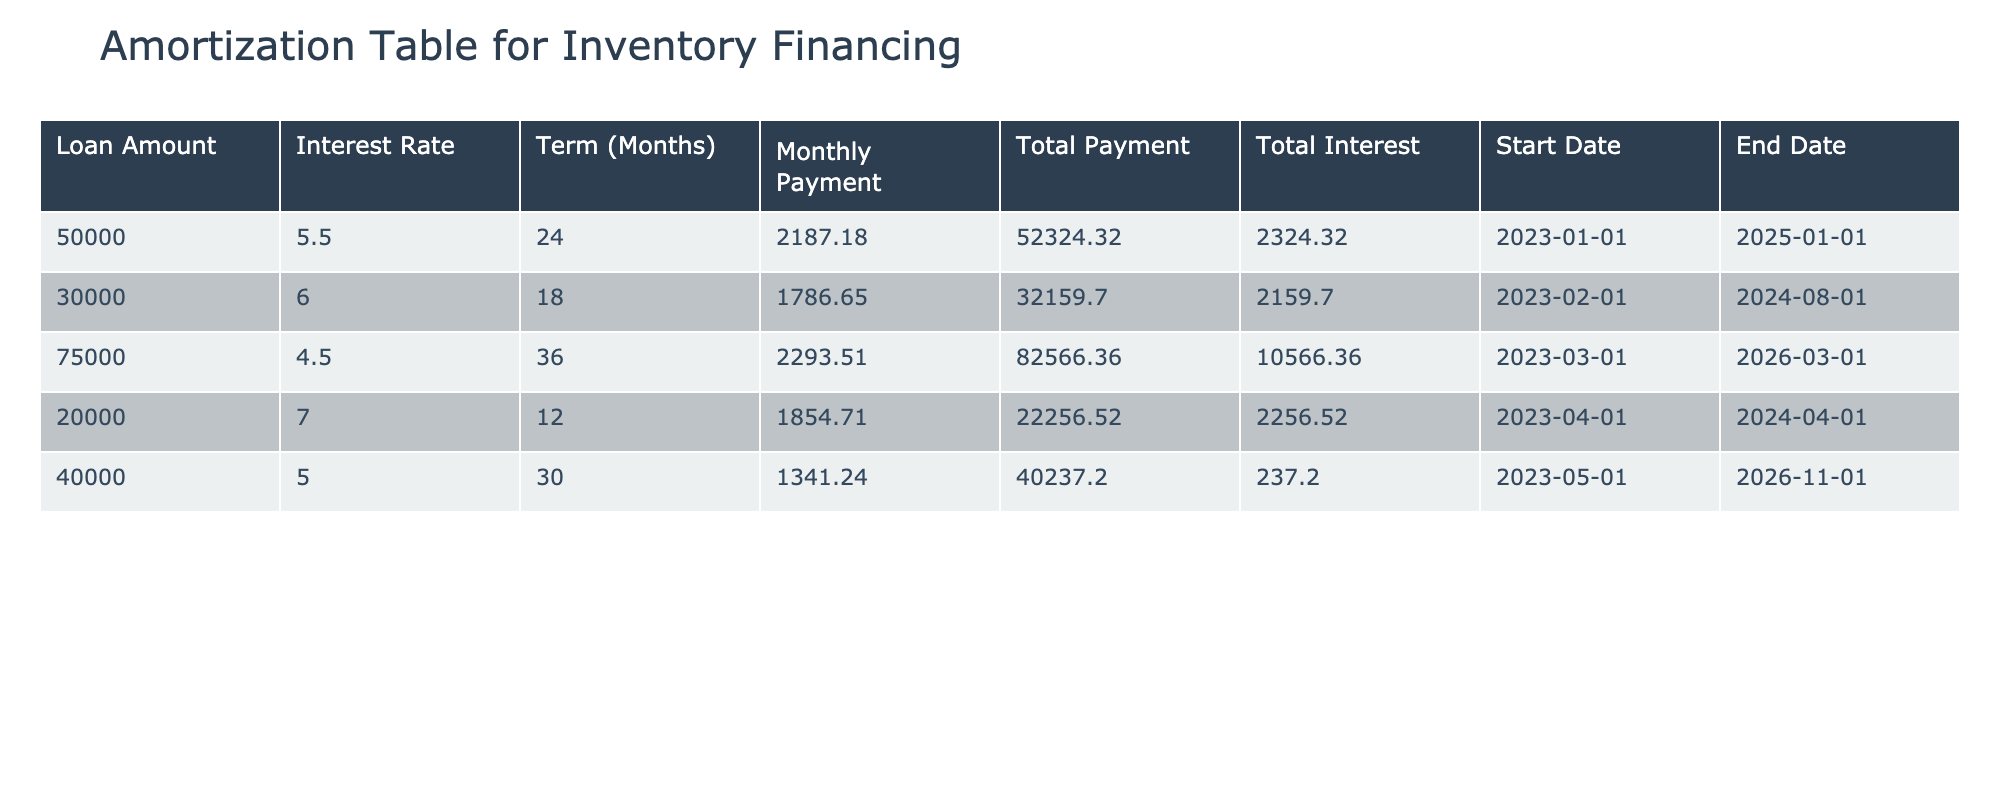What is the loan amount for the inventory financing with the highest total interest? By examining the "Total Interest" column, the highest value is 10566.36, which corresponds to the loan amount of 75000 in the same row.
Answer: 75000 What is the total payment for the loan taken out on February 1, 2023? Looking at the entry for the loan starting on February 1, 2023, the "Total Payment" column shows a value of 32159.70.
Answer: 32159.70 What is the average monthly payment across all loans? Summing up all monthly payments gives (2187.18 + 1786.65 + 2293.51 + 1854.71 + 1341.24) = 10463.29. Dividing by the number of loans (5) gives an average monthly payment of 2092.66.
Answer: 2092.66 Is there a loan with a term longer than 30 months? By checking the "Term (Months)" column, we see that there are loans with terms of 36 and 30 months, indicating that there is indeed at least one loan longer than 30 months.
Answer: Yes What is the total interest paid across all loans? Adding up all the "Total Interest" values, we have (2324.32 + 2159.70 + 10566.36 + 2256.52 + 237.20) = 18143.10, which represents the total interest paid across the loans.
Answer: 18143.10 What is the term of the loan with the lowest monthly payment? From the "Monthly Payment" column, the lowest value is 1341.24, which corresponds to a term of 30 months in the same row.
Answer: 30 months How much more is paid in total for the loan with the highest loan amount compared to the lowest loan amount? The highest loan amount is 75000 with a total payment of 82566.36 and the lowest is 20000 with a total payment of 22256.52. Calculating the difference: 82566.36 - 22256.52 = 60309.84.
Answer: 60309.84 Which loan has the highest interest rate, and what is that rate? By reviewing the "Interest Rate" column, the highest rate is 7.0, which corresponds to the loan taken out on April 1, 2023.
Answer: 7.0 When is the loan with the earliest start date expected to end? The earliest start date is January 1, 2023, which corresponds to an end date of January 1, 2025.
Answer: January 1, 2025 